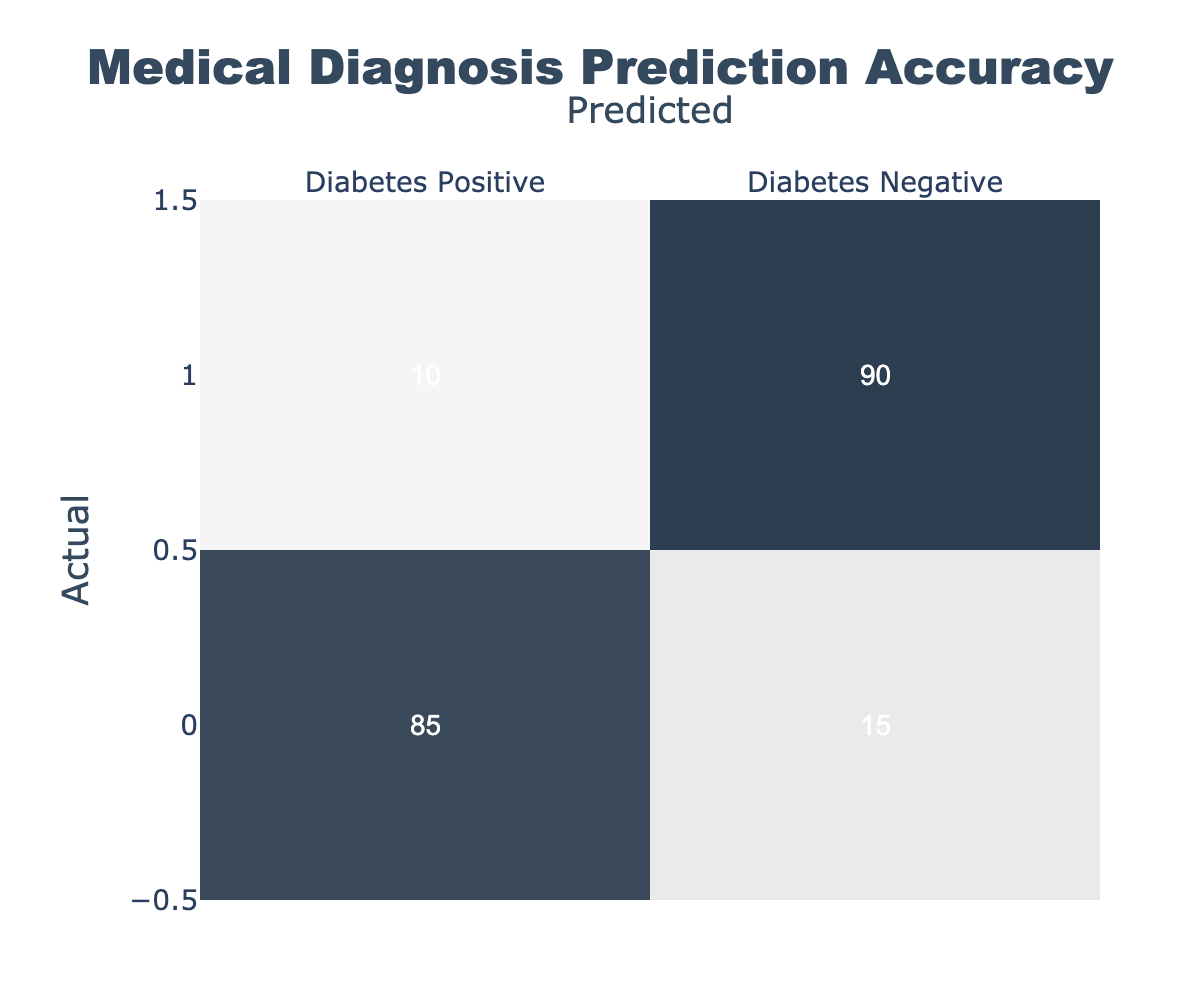What is the number of true positive predictions for diabetes? The true positive predictions refer to the cases where the actual condition is diabetes positive and the prediction is also diabetes positive. According to the table, this is represented in the first row and first column, which shows a value of 85.
Answer: 85 How many diabetes negative cases were correctly predicted? The correctly predicted diabetes negative cases are found in the second row and second column of the table, indicating the actual condition was diabetes negative, and it was predicted as such. The value in that cell is 90.
Answer: 90 What is the total number of cases predicted as diabetes positive? To find the total predicted cases for diabetes positive, we sum the values in the first column (noted from the first row). This includes both the true positive (85) and false positive (10) predictions: 85 + 10 = 95.
Answer: 95 What is the false negative rate in this data? The false negative rate is calculated by dividing the number of false negatives (where the actual condition is diabetes positive but predicted as negative) by the total actual positive cases. From the table, there are 15 false negatives out of a total of 100 actual positives (85 true positives + 15 false negatives). Hence, the false negative rate is 15/100 = 0.15 or 15%.
Answer: 15% Is the number of diabetes positive predictions greater than the number of diabetes negative predictions? To determine this, we compare the values. There are 95 predicted as diabetes positive (from the second question) and 100 predicted as diabetes negative (summing 90 true negatives + 10 false negatives). Therefore, the number of diabetes positive predictions (95) is not greater than the number of diabetes negative predictions (100).
Answer: No What is the total number of predicted cases in this study? The total predicted cases is the sum of all values in the confusion matrix. Adding these values: 85 + 15 + 10 + 90 = 200 gives the total number of predicted cases.
Answer: 200 What is the accuracy of this prediction model? The accuracy is obtained by dividing the number of correct predictions (true positives + true negatives) by the total number of cases. This means: (85 + 90) / 200 = 175 / 200 = 0.875 or 87.5%.
Answer: 87.5% How many cases were incorrectly predicted as diabetes positive? The cases incorrectly predicted as diabetes positive are indicated by the false positive count, shown in the second row and first column of the table, which is 10.
Answer: 10 What is the ratio of true positives to false positives? To find the ratio, we need the true positives value (85) and the false positives value (10). The ratio is calculated as 85:10 or simplified to 17:2 upon division.
Answer: 17:2 